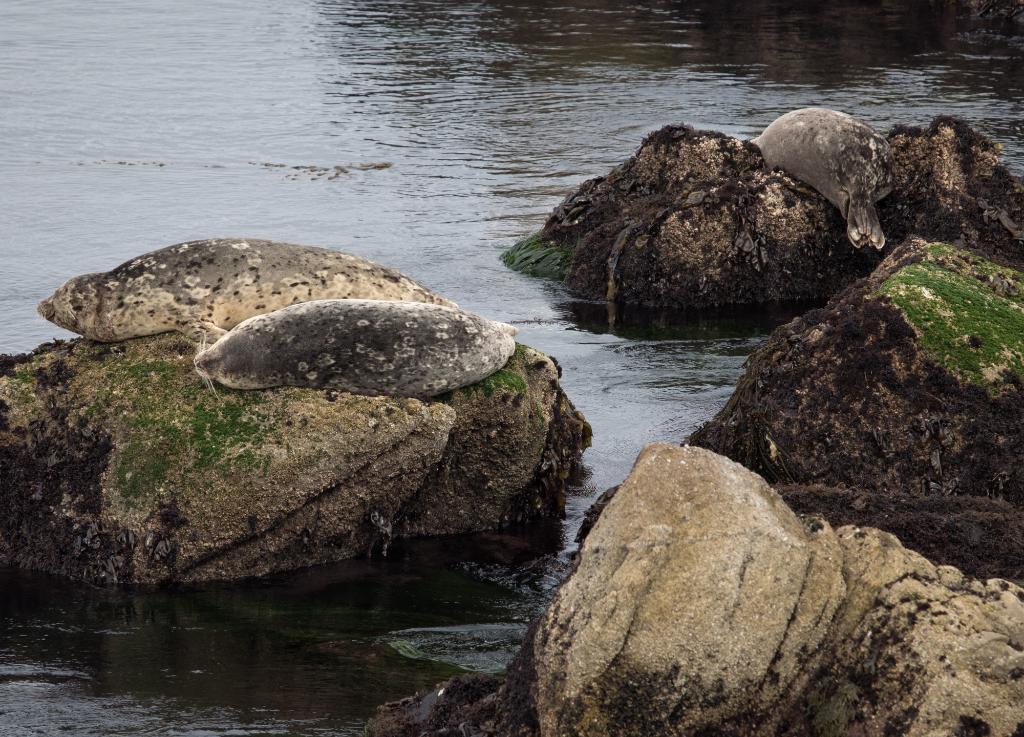How would you summarize this image in a sentence or two? In this picture we can see river. On the bottom we can see big stones. 